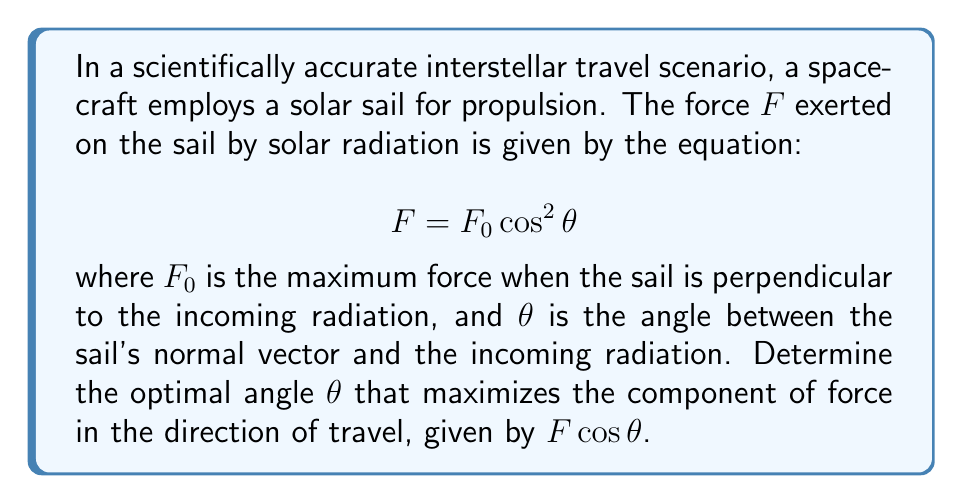Could you help me with this problem? To solve this problem, we need to find the maximum value of the function representing the force component in the direction of travel. Let's approach this step-by-step:

1) The force component in the direction of travel is given by:
   $$F_{\text{travel}} = F \cos\theta = F_0 \cos^2\theta \cos\theta = F_0 \cos^3\theta$$

2) To find the maximum, we need to find the derivative of this function with respect to $\theta$ and set it to zero:
   $$\frac{d}{d\theta}(F_0 \cos^3\theta) = F_0 \cdot 3 \cos^2\theta \cdot (-\sin\theta) = -3F_0 \cos^2\theta \sin\theta$$

3) Setting this equal to zero:
   $$-3F_0 \cos^2\theta \sin\theta = 0$$

4) This equation is satisfied when either $\cos\theta = 0$ or $\sin\theta = 0$. However, $\cos\theta = 0$ would result in zero force, so we focus on $\sin\theta = 0$.

5) $\sin\theta = 0$ occurs when $\theta = 0°, 180°, 360°$, etc. But we're interested in the angle between 0° and 90° for practical sail orientation.

6) To confirm this is a maximum (not a minimum), we can check the second derivative:
   $$\frac{d^2}{d\theta^2}(F_0 \cos^3\theta) = -3F_0 (2\cos\theta \sin^2\theta - \cos^3\theta)$$
   At $\theta = 0°$, this is negative, confirming a maximum.

7) Therefore, the optimal angle is $\theta = 0°$, meaning the sail should be oriented perpendicular to the incoming radiation.
Answer: $\theta = 0°$ 